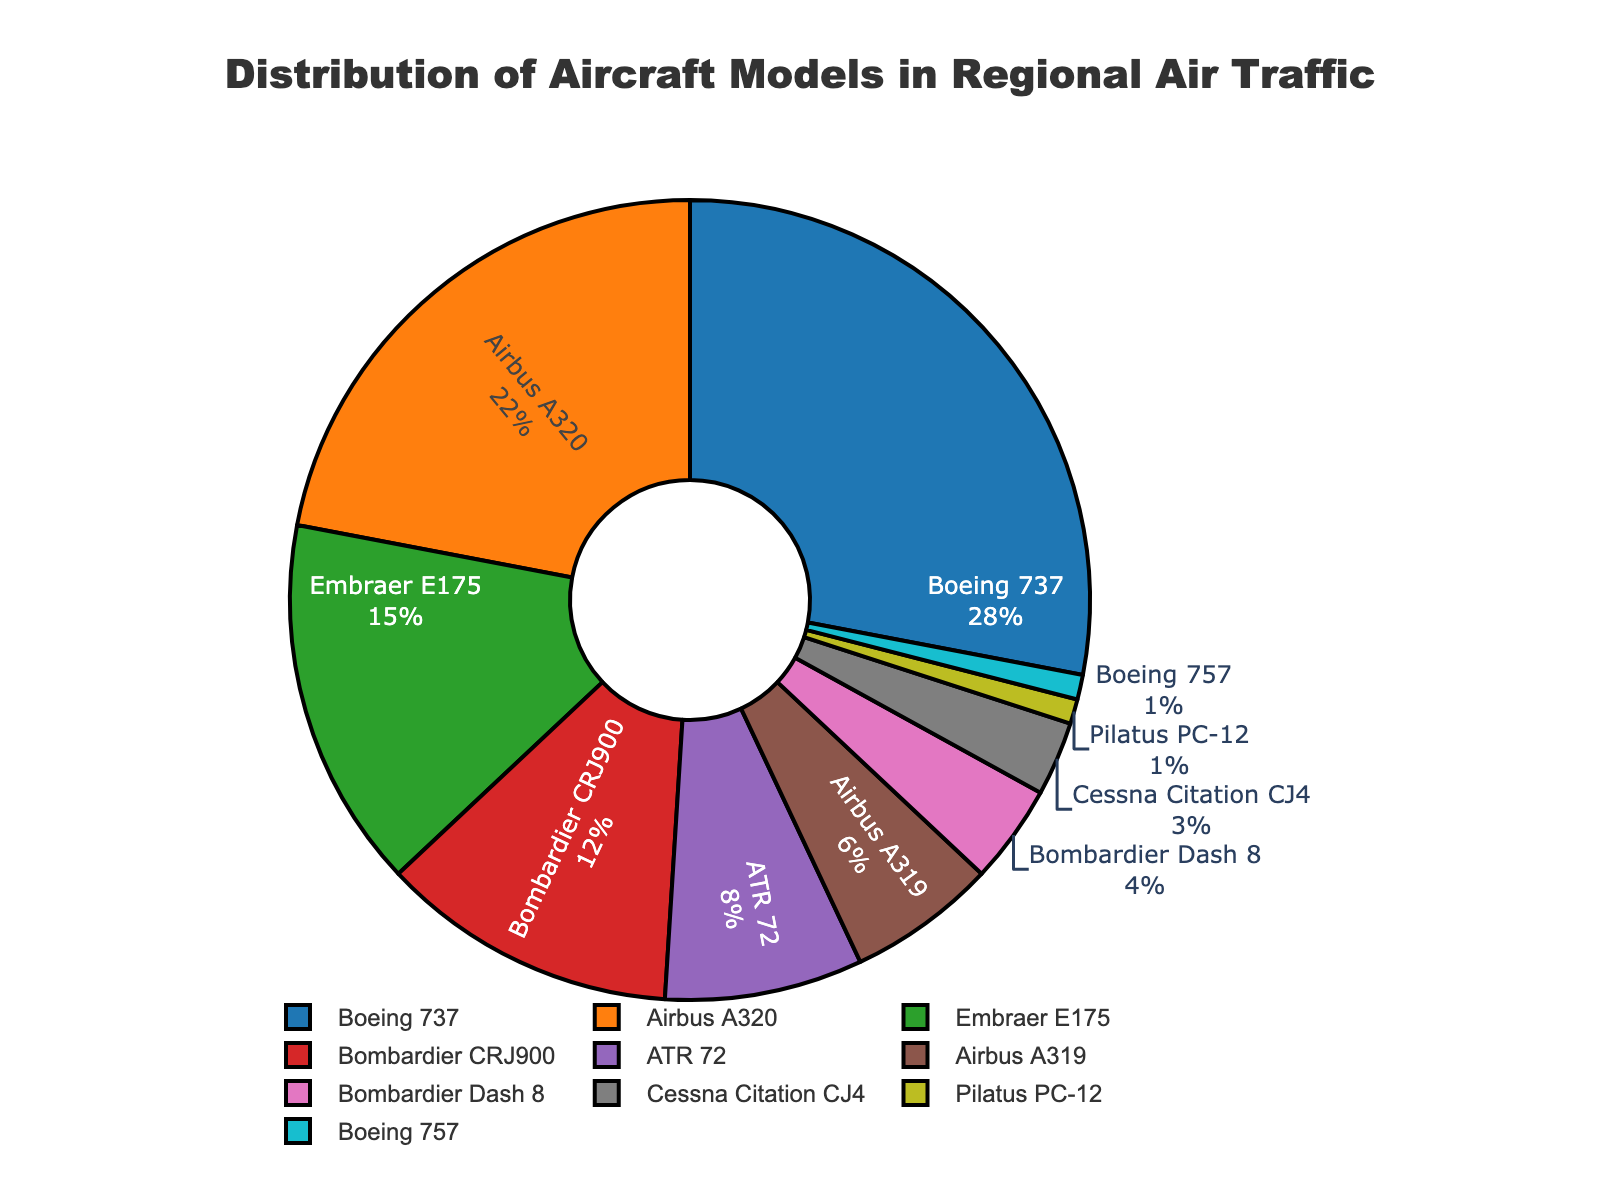What percentage of the aircraft models are Boeing 737? Look at the segment represented by Boeing 737 in the pie chart. It shows the percentage value assigned to this model directly.
Answer: 28% Which aircraft model has the smallest share in regional air traffic? Identify the slice in the pie chart that represents the smallest portion. It is labeled with the model having the least percentage.
Answer: Pilatus PC-12 and Boeing 757 What is the combined percentage of Airbus models (A320 and A319) in regional air traffic? Add the percentages of Airbus A320 and Airbus A319 as given in the pie chart: 22% + 6%.
Answer: 28% Which aircraft model holds a larger percentage: Bombardier CRJ900 or Embraer E175? Compare the percentage values of Bombardier CRJ900 and Embraer E175 shown in the pie chart. Bombardier CRJ900 is 12% and Embraer E175 is 15%.
Answer: Embraer E175 How much greater is the percentage of Boeing 737 compared to Embraer E175? Subtract the percentage of Embraer E175 from Boeing 737. Boeing 737 is 28% and Embraer E175 is 15%. 28% - 15% = 13%
Answer: 13% What percentage of the aircraft models are regional jets (Embraer E175 and Bombardier CRJ900 combined)? Add the percentages of both Embraer E175 and Bombardier CRJ900: 15% + 12%.
Answer: 27% What is the color representing the ATR 72 in the pie chart? Identify the color associated with the ATR 72 in the pie chart's legend.
Answer: Purple Which model has a larger share: Boeing 737 or the combined share of Airbus models (A320 and A319)? Calculate the combined share of Airbus models: 22% (A320) + 6% (A319) = 28%. Compare this with Boeing 737's 28%.
Answer: Both have the same share What is the cumulative percentage of propeller planes (ATR 72, Bombardier Dash 8, and Pilatus PC-12)? Add the percentages of the propeller planes, ATR 72 (8%), Bombardier Dash 8 (4%), and Pilatus PC-12 (1%). 8% + 4% + 1% = 13%
Answer: 13% 